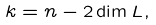<formula> <loc_0><loc_0><loc_500><loc_500>k = n - 2 \dim L ,</formula> 